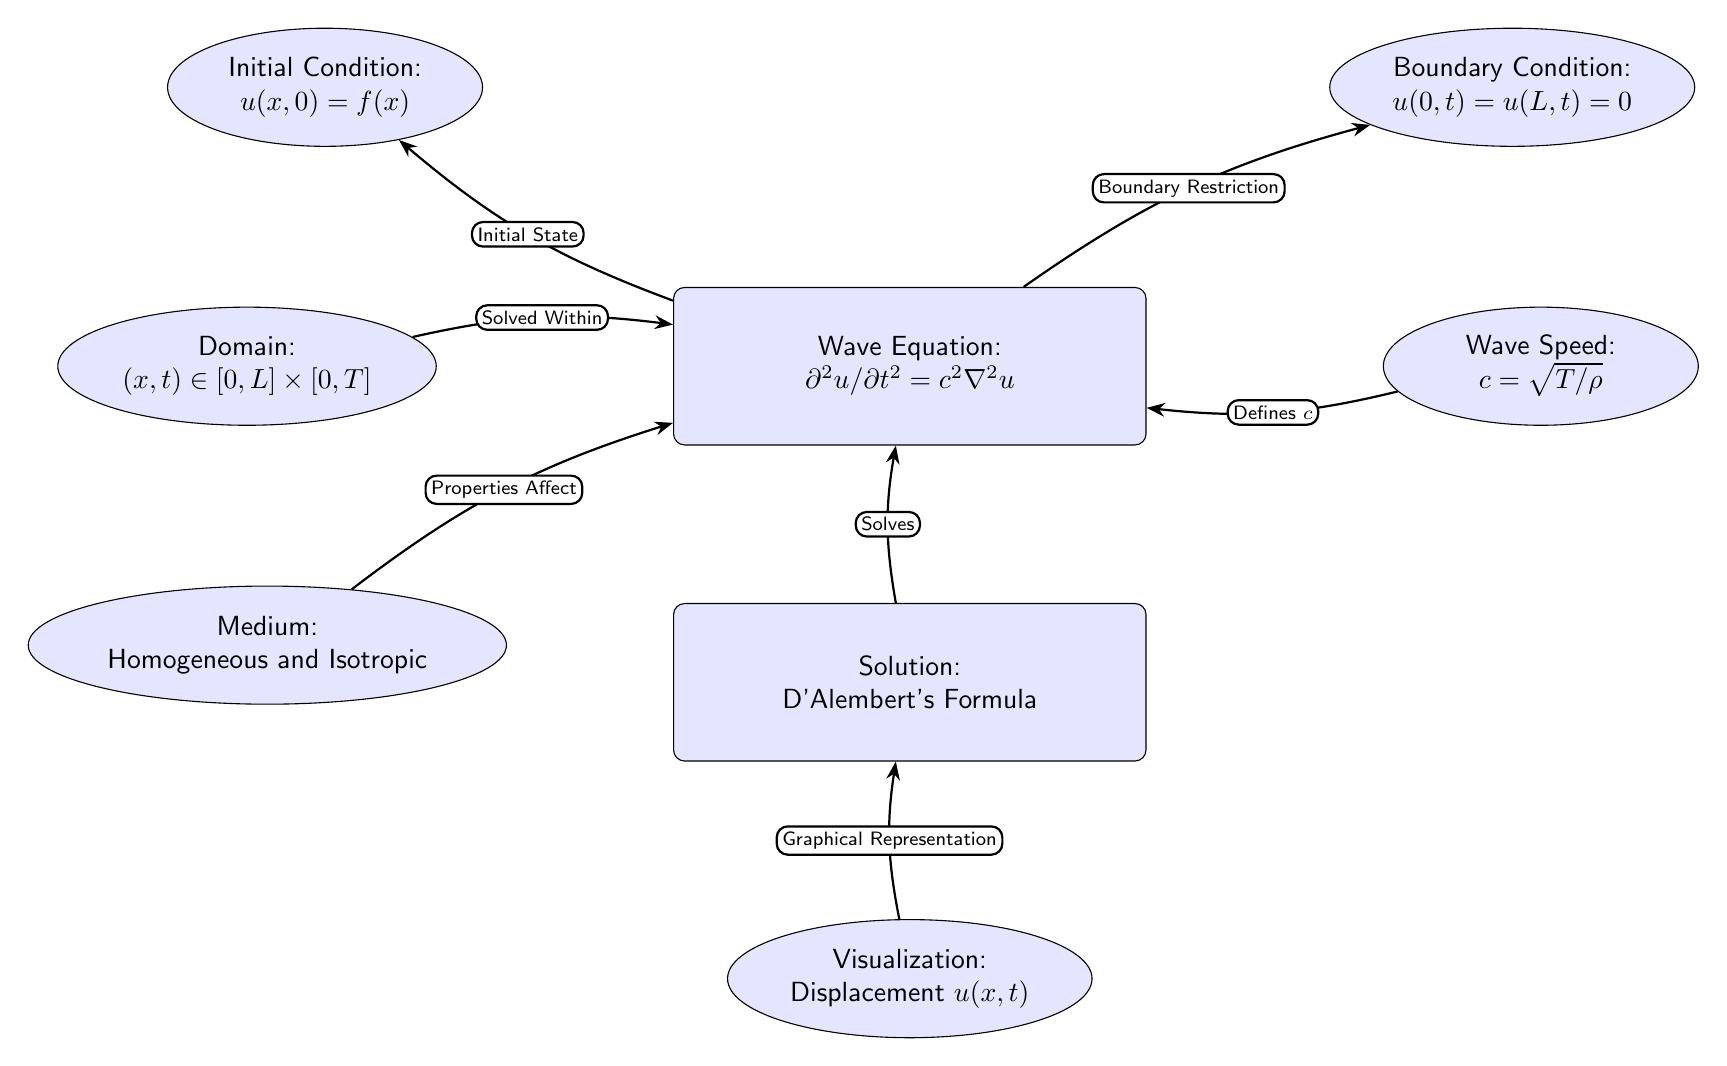What is the equation represented in the central node of the diagram? The central node is labeled as "Wave Equation" and it displays the equation $\partial^2u/\partial t^2 = c^2\nabla^2u$, which represents the wave propagation in a medium.
Answer: Wave Equation: $\partial^2u/\partial t^2 = c^2\nabla^2u$ What does the medium node specify? The medium node identifies the properties of the wave propagation medium, specified as "Homogeneous and Isotropic," meaning it has the same properties in all directions and at all points.
Answer: Homogeneous and Isotropic How many initial conditions are stated in the diagram? There is one initial condition depicted in the diagram, labeled as "Initial Condition: $u(x,0) = f(x)$," which describes the state of the wave at time t=0.
Answer: 1 What relationship does the speed node have with the wave equation? The speed node states that "c = $\sqrt{T/\rho}$", indicating that the wave speed c is defined in terms of tension T and density $\rho$, thereby connecting the physical properties of the medium to the wave equation.
Answer: Defines c What do the arrows between the wave node and the boundary conditions indicate? The arrows indicate the influence that the boundary conditions (where the wave is fixed at both ends) have on the wave equation, restricting the wave behavior at the boundaries as specified by "Boundary Condition: $u(0,t) = u(L,t) = 0$".
Answer: Boundary Restriction What graphical representation is linked to the solution node? The solution node connects to the visualization node, which indicates that the graphical representation of the wave displacement, denoted as $u(x,t)$, is derived from the solution of the wave equation.
Answer: Displacement $u(x,t)$ What is the relationship between the domain and the wave equation? The domain specifies the range in which the wave equation is solved, denoted as $(x,t) \in [0,L] \times [0,T]$, establishing the spatial and temporal limits for analysis of wave propagation.
Answer: Solved Within What role does the solution node play in the diagram? The solution node represents the process of solving the wave equation, and it is linked to D'Alembert's Formula, indicating that a specific mathematical approach is used to find the wave's behavior over time and space.
Answer: Solves 